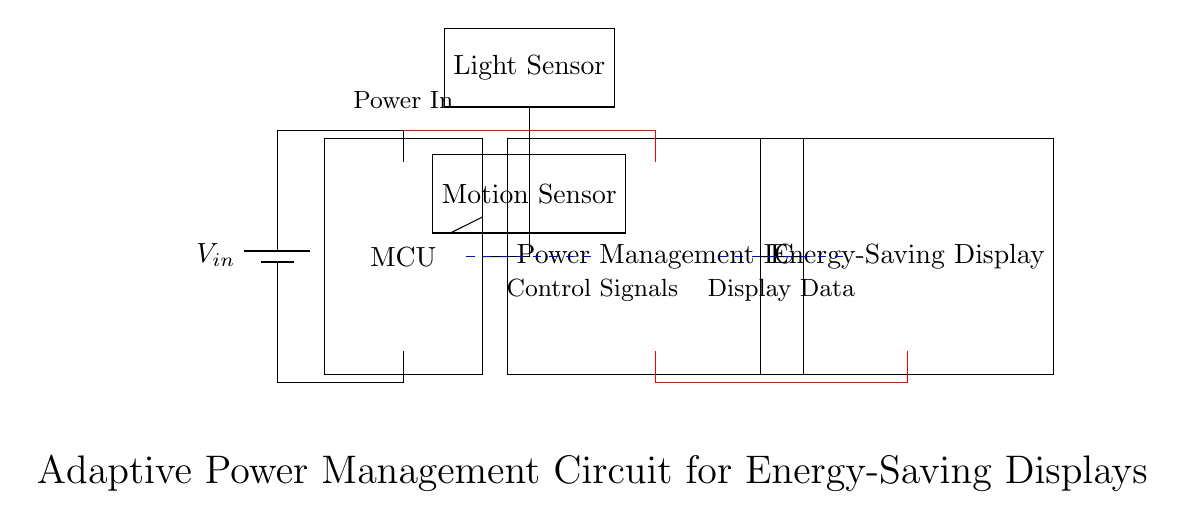What is the input voltage of the circuit? The input voltage is indicated by the label 'V_in' next to the battery at the top-left corner of the diagram.
Answer: V_in Which sensor is connected to the microcontroller? The microcontroller has connections to both the light sensor and the motion sensor, as shown by the lines leading out from the MCU node.
Answer: Light sensor, Motion sensor What function does the power management IC serve in this circuit? The power management IC regulates power supply to the display, receiving input from the microcontroller and directing power to the energy-saving display as indicated by its position in the diagram and its label.
Answer: Regulates power How many main components are visible in the circuit diagram? Counting the labeled components, we find five main components: a battery, a microcontroller, a light sensor, a motion sensor, and a power management IC along with the display.
Answer: Five What type of control signals is indicated in the circuit? The dashed blue lines between the MCU and the PMIC, as well as the other signals, indicate control signals that manage the operation of the components; these lines are not connected to power but denote communication.
Answer: Control signals What is the connection type between the microcontroller and sensors? The connection type is direct as indicated by the solid lines leading directly from the microcontroller to the light and motion sensors without any intermediate components, illustrating that they are wired for direct communication.
Answer: Direct connections 